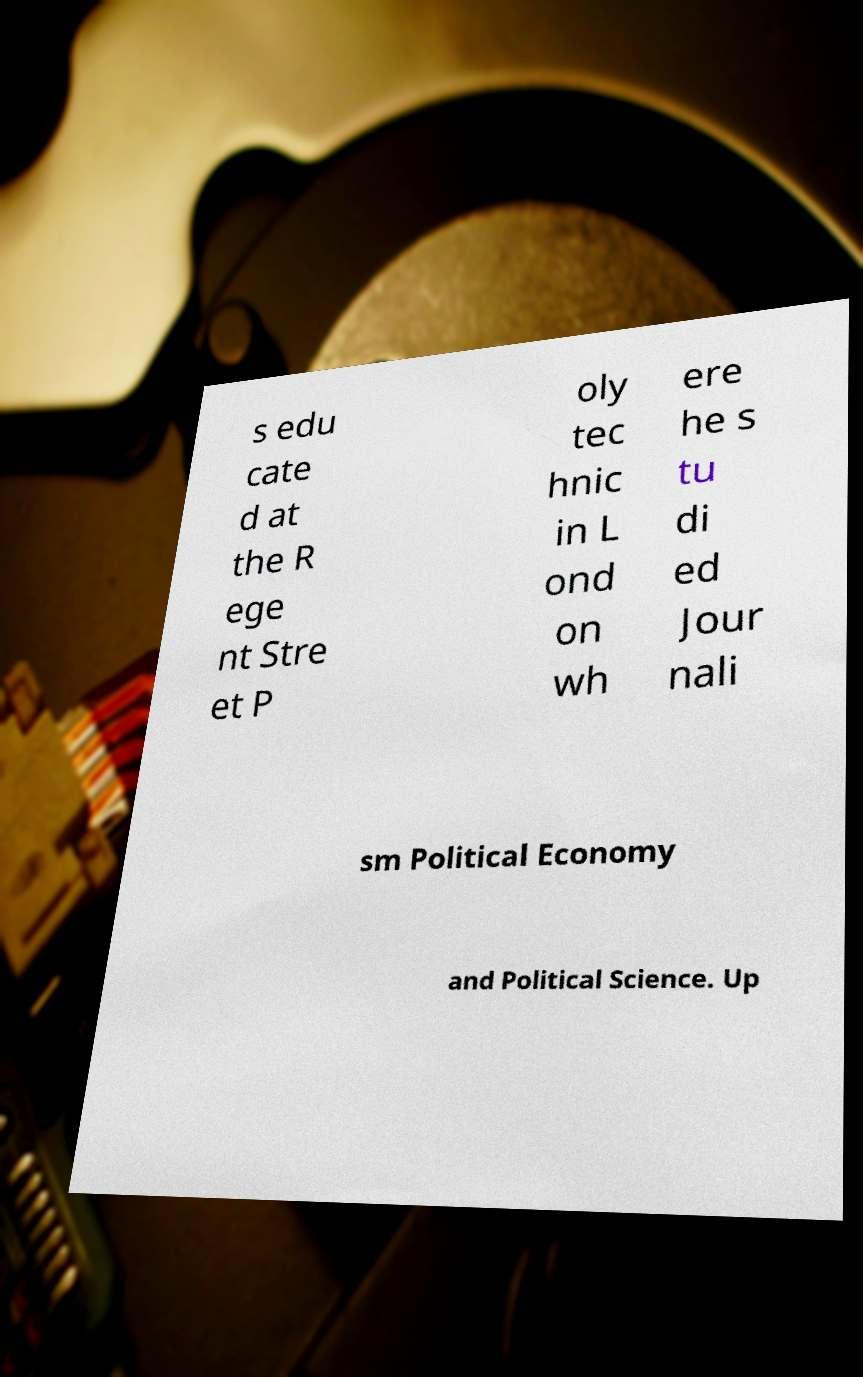I need the written content from this picture converted into text. Can you do that? s edu cate d at the R ege nt Stre et P oly tec hnic in L ond on wh ere he s tu di ed Jour nali sm Political Economy and Political Science. Up 